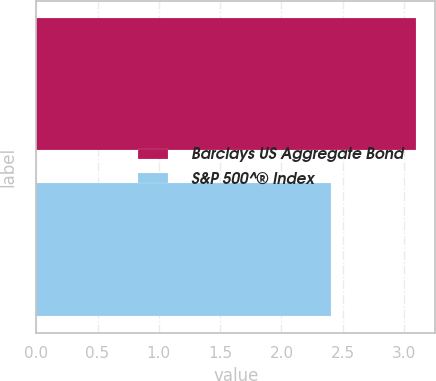Convert chart to OTSL. <chart><loc_0><loc_0><loc_500><loc_500><bar_chart><fcel>Barclays US Aggregate Bond<fcel>S&P 500^® Index<nl><fcel>3.1<fcel>2.4<nl></chart> 